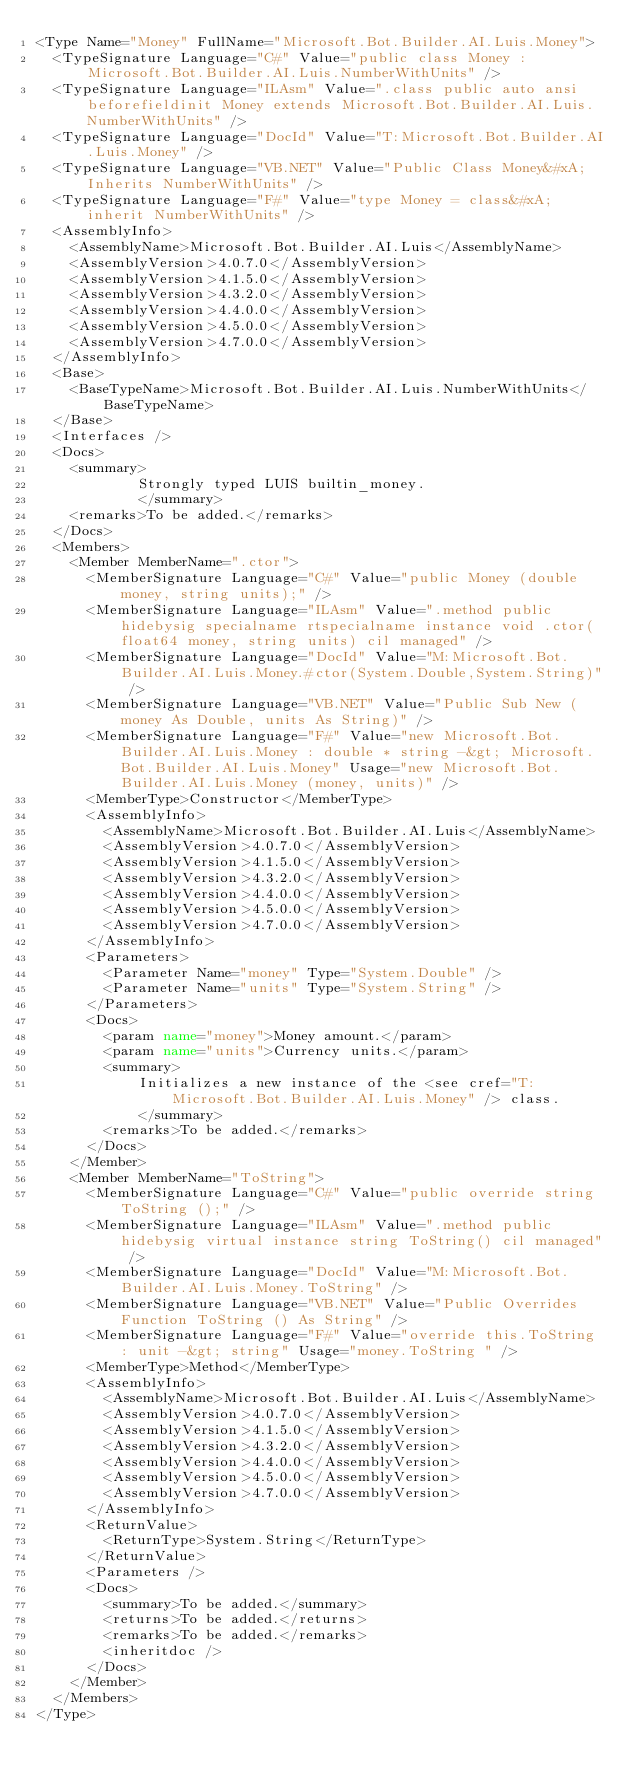<code> <loc_0><loc_0><loc_500><loc_500><_XML_><Type Name="Money" FullName="Microsoft.Bot.Builder.AI.Luis.Money">
  <TypeSignature Language="C#" Value="public class Money : Microsoft.Bot.Builder.AI.Luis.NumberWithUnits" />
  <TypeSignature Language="ILAsm" Value=".class public auto ansi beforefieldinit Money extends Microsoft.Bot.Builder.AI.Luis.NumberWithUnits" />
  <TypeSignature Language="DocId" Value="T:Microsoft.Bot.Builder.AI.Luis.Money" />
  <TypeSignature Language="VB.NET" Value="Public Class Money&#xA;Inherits NumberWithUnits" />
  <TypeSignature Language="F#" Value="type Money = class&#xA;    inherit NumberWithUnits" />
  <AssemblyInfo>
    <AssemblyName>Microsoft.Bot.Builder.AI.Luis</AssemblyName>
    <AssemblyVersion>4.0.7.0</AssemblyVersion>
    <AssemblyVersion>4.1.5.0</AssemblyVersion>
    <AssemblyVersion>4.3.2.0</AssemblyVersion>
    <AssemblyVersion>4.4.0.0</AssemblyVersion>
    <AssemblyVersion>4.5.0.0</AssemblyVersion>
    <AssemblyVersion>4.7.0.0</AssemblyVersion>
  </AssemblyInfo>
  <Base>
    <BaseTypeName>Microsoft.Bot.Builder.AI.Luis.NumberWithUnits</BaseTypeName>
  </Base>
  <Interfaces />
  <Docs>
    <summary>
            Strongly typed LUIS builtin_money.
            </summary>
    <remarks>To be added.</remarks>
  </Docs>
  <Members>
    <Member MemberName=".ctor">
      <MemberSignature Language="C#" Value="public Money (double money, string units);" />
      <MemberSignature Language="ILAsm" Value=".method public hidebysig specialname rtspecialname instance void .ctor(float64 money, string units) cil managed" />
      <MemberSignature Language="DocId" Value="M:Microsoft.Bot.Builder.AI.Luis.Money.#ctor(System.Double,System.String)" />
      <MemberSignature Language="VB.NET" Value="Public Sub New (money As Double, units As String)" />
      <MemberSignature Language="F#" Value="new Microsoft.Bot.Builder.AI.Luis.Money : double * string -&gt; Microsoft.Bot.Builder.AI.Luis.Money" Usage="new Microsoft.Bot.Builder.AI.Luis.Money (money, units)" />
      <MemberType>Constructor</MemberType>
      <AssemblyInfo>
        <AssemblyName>Microsoft.Bot.Builder.AI.Luis</AssemblyName>
        <AssemblyVersion>4.0.7.0</AssemblyVersion>
        <AssemblyVersion>4.1.5.0</AssemblyVersion>
        <AssemblyVersion>4.3.2.0</AssemblyVersion>
        <AssemblyVersion>4.4.0.0</AssemblyVersion>
        <AssemblyVersion>4.5.0.0</AssemblyVersion>
        <AssemblyVersion>4.7.0.0</AssemblyVersion>
      </AssemblyInfo>
      <Parameters>
        <Parameter Name="money" Type="System.Double" />
        <Parameter Name="units" Type="System.String" />
      </Parameters>
      <Docs>
        <param name="money">Money amount.</param>
        <param name="units">Currency units.</param>
        <summary>
            Initializes a new instance of the <see cref="T:Microsoft.Bot.Builder.AI.Luis.Money" /> class.
            </summary>
        <remarks>To be added.</remarks>
      </Docs>
    </Member>
    <Member MemberName="ToString">
      <MemberSignature Language="C#" Value="public override string ToString ();" />
      <MemberSignature Language="ILAsm" Value=".method public hidebysig virtual instance string ToString() cil managed" />
      <MemberSignature Language="DocId" Value="M:Microsoft.Bot.Builder.AI.Luis.Money.ToString" />
      <MemberSignature Language="VB.NET" Value="Public Overrides Function ToString () As String" />
      <MemberSignature Language="F#" Value="override this.ToString : unit -&gt; string" Usage="money.ToString " />
      <MemberType>Method</MemberType>
      <AssemblyInfo>
        <AssemblyName>Microsoft.Bot.Builder.AI.Luis</AssemblyName>
        <AssemblyVersion>4.0.7.0</AssemblyVersion>
        <AssemblyVersion>4.1.5.0</AssemblyVersion>
        <AssemblyVersion>4.3.2.0</AssemblyVersion>
        <AssemblyVersion>4.4.0.0</AssemblyVersion>
        <AssemblyVersion>4.5.0.0</AssemblyVersion>
        <AssemblyVersion>4.7.0.0</AssemblyVersion>
      </AssemblyInfo>
      <ReturnValue>
        <ReturnType>System.String</ReturnType>
      </ReturnValue>
      <Parameters />
      <Docs>
        <summary>To be added.</summary>
        <returns>To be added.</returns>
        <remarks>To be added.</remarks>
        <inheritdoc />
      </Docs>
    </Member>
  </Members>
</Type>
</code> 